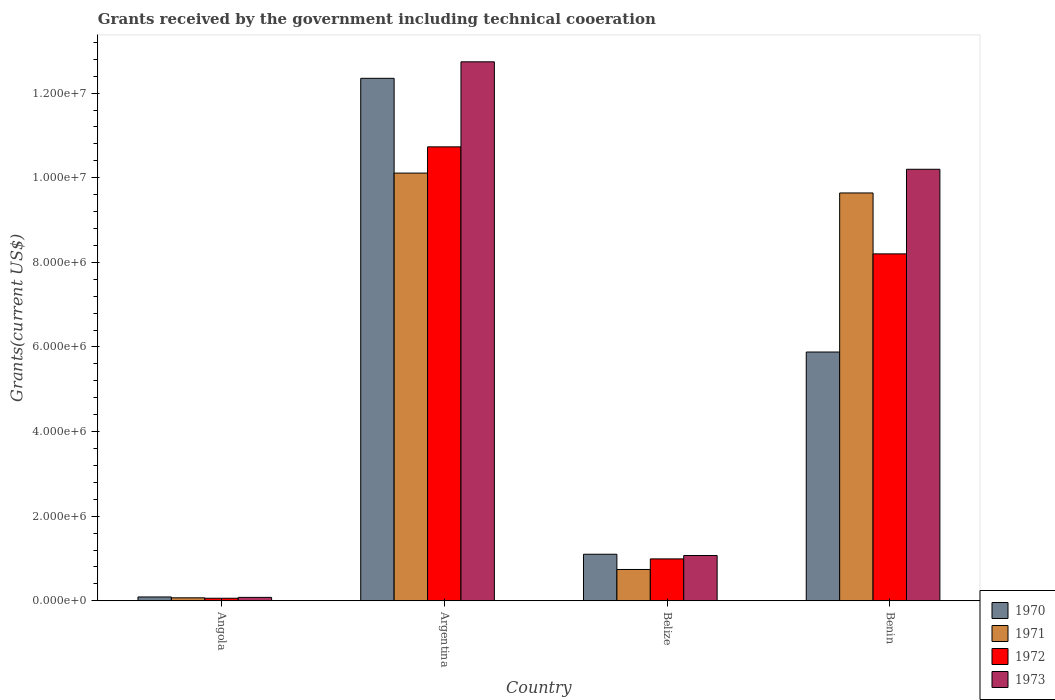How many different coloured bars are there?
Provide a succinct answer. 4. How many groups of bars are there?
Ensure brevity in your answer.  4. Are the number of bars per tick equal to the number of legend labels?
Give a very brief answer. Yes. Are the number of bars on each tick of the X-axis equal?
Provide a succinct answer. Yes. How many bars are there on the 3rd tick from the left?
Provide a succinct answer. 4. How many bars are there on the 4th tick from the right?
Your response must be concise. 4. What is the label of the 4th group of bars from the left?
Your response must be concise. Benin. In how many cases, is the number of bars for a given country not equal to the number of legend labels?
Offer a terse response. 0. What is the total grants received by the government in 1970 in Belize?
Your answer should be very brief. 1.10e+06. Across all countries, what is the maximum total grants received by the government in 1970?
Offer a very short reply. 1.24e+07. In which country was the total grants received by the government in 1970 minimum?
Provide a succinct answer. Angola. What is the total total grants received by the government in 1970 in the graph?
Give a very brief answer. 1.94e+07. What is the difference between the total grants received by the government in 1970 in Angola and that in Belize?
Your response must be concise. -1.01e+06. What is the difference between the total grants received by the government in 1973 in Benin and the total grants received by the government in 1970 in Belize?
Make the answer very short. 9.10e+06. What is the average total grants received by the government in 1971 per country?
Keep it short and to the point. 5.14e+06. What is the difference between the total grants received by the government of/in 1970 and total grants received by the government of/in 1973 in Benin?
Provide a short and direct response. -4.32e+06. What is the ratio of the total grants received by the government in 1970 in Angola to that in Belize?
Provide a succinct answer. 0.08. Is the total grants received by the government in 1973 in Angola less than that in Argentina?
Your answer should be very brief. Yes. What is the difference between the highest and the lowest total grants received by the government in 1971?
Your answer should be compact. 1.00e+07. In how many countries, is the total grants received by the government in 1973 greater than the average total grants received by the government in 1973 taken over all countries?
Provide a succinct answer. 2. What does the 1st bar from the right in Belize represents?
Give a very brief answer. 1973. Is it the case that in every country, the sum of the total grants received by the government in 1970 and total grants received by the government in 1972 is greater than the total grants received by the government in 1971?
Offer a very short reply. Yes. How many bars are there?
Keep it short and to the point. 16. Does the graph contain any zero values?
Your answer should be compact. No. Does the graph contain grids?
Your response must be concise. No. Where does the legend appear in the graph?
Provide a succinct answer. Bottom right. How many legend labels are there?
Offer a terse response. 4. What is the title of the graph?
Offer a terse response. Grants received by the government including technical cooeration. What is the label or title of the Y-axis?
Your answer should be compact. Grants(current US$). What is the Grants(current US$) of 1973 in Angola?
Provide a short and direct response. 8.00e+04. What is the Grants(current US$) of 1970 in Argentina?
Keep it short and to the point. 1.24e+07. What is the Grants(current US$) of 1971 in Argentina?
Offer a terse response. 1.01e+07. What is the Grants(current US$) in 1972 in Argentina?
Your answer should be very brief. 1.07e+07. What is the Grants(current US$) in 1973 in Argentina?
Provide a short and direct response. 1.27e+07. What is the Grants(current US$) in 1970 in Belize?
Give a very brief answer. 1.10e+06. What is the Grants(current US$) in 1971 in Belize?
Give a very brief answer. 7.40e+05. What is the Grants(current US$) of 1972 in Belize?
Provide a succinct answer. 9.90e+05. What is the Grants(current US$) of 1973 in Belize?
Ensure brevity in your answer.  1.07e+06. What is the Grants(current US$) in 1970 in Benin?
Your response must be concise. 5.88e+06. What is the Grants(current US$) in 1971 in Benin?
Your answer should be compact. 9.64e+06. What is the Grants(current US$) in 1972 in Benin?
Your response must be concise. 8.20e+06. What is the Grants(current US$) of 1973 in Benin?
Make the answer very short. 1.02e+07. Across all countries, what is the maximum Grants(current US$) of 1970?
Your answer should be very brief. 1.24e+07. Across all countries, what is the maximum Grants(current US$) in 1971?
Give a very brief answer. 1.01e+07. Across all countries, what is the maximum Grants(current US$) of 1972?
Your answer should be compact. 1.07e+07. Across all countries, what is the maximum Grants(current US$) in 1973?
Offer a very short reply. 1.27e+07. What is the total Grants(current US$) of 1970 in the graph?
Provide a succinct answer. 1.94e+07. What is the total Grants(current US$) in 1971 in the graph?
Offer a terse response. 2.06e+07. What is the total Grants(current US$) of 1972 in the graph?
Provide a succinct answer. 2.00e+07. What is the total Grants(current US$) in 1973 in the graph?
Your answer should be very brief. 2.41e+07. What is the difference between the Grants(current US$) in 1970 in Angola and that in Argentina?
Give a very brief answer. -1.23e+07. What is the difference between the Grants(current US$) of 1971 in Angola and that in Argentina?
Offer a very short reply. -1.00e+07. What is the difference between the Grants(current US$) in 1972 in Angola and that in Argentina?
Your response must be concise. -1.07e+07. What is the difference between the Grants(current US$) in 1973 in Angola and that in Argentina?
Give a very brief answer. -1.27e+07. What is the difference between the Grants(current US$) of 1970 in Angola and that in Belize?
Make the answer very short. -1.01e+06. What is the difference between the Grants(current US$) in 1971 in Angola and that in Belize?
Your response must be concise. -6.70e+05. What is the difference between the Grants(current US$) of 1972 in Angola and that in Belize?
Give a very brief answer. -9.30e+05. What is the difference between the Grants(current US$) of 1973 in Angola and that in Belize?
Your response must be concise. -9.90e+05. What is the difference between the Grants(current US$) in 1970 in Angola and that in Benin?
Ensure brevity in your answer.  -5.79e+06. What is the difference between the Grants(current US$) of 1971 in Angola and that in Benin?
Ensure brevity in your answer.  -9.57e+06. What is the difference between the Grants(current US$) in 1972 in Angola and that in Benin?
Provide a succinct answer. -8.14e+06. What is the difference between the Grants(current US$) in 1973 in Angola and that in Benin?
Ensure brevity in your answer.  -1.01e+07. What is the difference between the Grants(current US$) in 1970 in Argentina and that in Belize?
Keep it short and to the point. 1.12e+07. What is the difference between the Grants(current US$) in 1971 in Argentina and that in Belize?
Provide a succinct answer. 9.37e+06. What is the difference between the Grants(current US$) of 1972 in Argentina and that in Belize?
Provide a short and direct response. 9.74e+06. What is the difference between the Grants(current US$) of 1973 in Argentina and that in Belize?
Provide a succinct answer. 1.17e+07. What is the difference between the Grants(current US$) in 1970 in Argentina and that in Benin?
Give a very brief answer. 6.47e+06. What is the difference between the Grants(current US$) in 1971 in Argentina and that in Benin?
Give a very brief answer. 4.70e+05. What is the difference between the Grants(current US$) of 1972 in Argentina and that in Benin?
Your answer should be very brief. 2.53e+06. What is the difference between the Grants(current US$) in 1973 in Argentina and that in Benin?
Keep it short and to the point. 2.54e+06. What is the difference between the Grants(current US$) of 1970 in Belize and that in Benin?
Ensure brevity in your answer.  -4.78e+06. What is the difference between the Grants(current US$) of 1971 in Belize and that in Benin?
Offer a terse response. -8.90e+06. What is the difference between the Grants(current US$) in 1972 in Belize and that in Benin?
Your answer should be compact. -7.21e+06. What is the difference between the Grants(current US$) in 1973 in Belize and that in Benin?
Offer a terse response. -9.13e+06. What is the difference between the Grants(current US$) of 1970 in Angola and the Grants(current US$) of 1971 in Argentina?
Your response must be concise. -1.00e+07. What is the difference between the Grants(current US$) in 1970 in Angola and the Grants(current US$) in 1972 in Argentina?
Offer a terse response. -1.06e+07. What is the difference between the Grants(current US$) of 1970 in Angola and the Grants(current US$) of 1973 in Argentina?
Provide a short and direct response. -1.26e+07. What is the difference between the Grants(current US$) of 1971 in Angola and the Grants(current US$) of 1972 in Argentina?
Give a very brief answer. -1.07e+07. What is the difference between the Grants(current US$) of 1971 in Angola and the Grants(current US$) of 1973 in Argentina?
Give a very brief answer. -1.27e+07. What is the difference between the Grants(current US$) of 1972 in Angola and the Grants(current US$) of 1973 in Argentina?
Provide a succinct answer. -1.27e+07. What is the difference between the Grants(current US$) in 1970 in Angola and the Grants(current US$) in 1971 in Belize?
Make the answer very short. -6.50e+05. What is the difference between the Grants(current US$) of 1970 in Angola and the Grants(current US$) of 1972 in Belize?
Keep it short and to the point. -9.00e+05. What is the difference between the Grants(current US$) of 1970 in Angola and the Grants(current US$) of 1973 in Belize?
Provide a short and direct response. -9.80e+05. What is the difference between the Grants(current US$) of 1971 in Angola and the Grants(current US$) of 1972 in Belize?
Give a very brief answer. -9.20e+05. What is the difference between the Grants(current US$) of 1972 in Angola and the Grants(current US$) of 1973 in Belize?
Your answer should be very brief. -1.01e+06. What is the difference between the Grants(current US$) in 1970 in Angola and the Grants(current US$) in 1971 in Benin?
Offer a very short reply. -9.55e+06. What is the difference between the Grants(current US$) in 1970 in Angola and the Grants(current US$) in 1972 in Benin?
Provide a short and direct response. -8.11e+06. What is the difference between the Grants(current US$) in 1970 in Angola and the Grants(current US$) in 1973 in Benin?
Offer a very short reply. -1.01e+07. What is the difference between the Grants(current US$) of 1971 in Angola and the Grants(current US$) of 1972 in Benin?
Give a very brief answer. -8.13e+06. What is the difference between the Grants(current US$) in 1971 in Angola and the Grants(current US$) in 1973 in Benin?
Ensure brevity in your answer.  -1.01e+07. What is the difference between the Grants(current US$) of 1972 in Angola and the Grants(current US$) of 1973 in Benin?
Your answer should be very brief. -1.01e+07. What is the difference between the Grants(current US$) in 1970 in Argentina and the Grants(current US$) in 1971 in Belize?
Keep it short and to the point. 1.16e+07. What is the difference between the Grants(current US$) of 1970 in Argentina and the Grants(current US$) of 1972 in Belize?
Offer a terse response. 1.14e+07. What is the difference between the Grants(current US$) of 1970 in Argentina and the Grants(current US$) of 1973 in Belize?
Provide a short and direct response. 1.13e+07. What is the difference between the Grants(current US$) in 1971 in Argentina and the Grants(current US$) in 1972 in Belize?
Keep it short and to the point. 9.12e+06. What is the difference between the Grants(current US$) in 1971 in Argentina and the Grants(current US$) in 1973 in Belize?
Your answer should be compact. 9.04e+06. What is the difference between the Grants(current US$) of 1972 in Argentina and the Grants(current US$) of 1973 in Belize?
Your answer should be very brief. 9.66e+06. What is the difference between the Grants(current US$) of 1970 in Argentina and the Grants(current US$) of 1971 in Benin?
Provide a succinct answer. 2.71e+06. What is the difference between the Grants(current US$) in 1970 in Argentina and the Grants(current US$) in 1972 in Benin?
Make the answer very short. 4.15e+06. What is the difference between the Grants(current US$) in 1970 in Argentina and the Grants(current US$) in 1973 in Benin?
Your answer should be very brief. 2.15e+06. What is the difference between the Grants(current US$) of 1971 in Argentina and the Grants(current US$) of 1972 in Benin?
Offer a very short reply. 1.91e+06. What is the difference between the Grants(current US$) in 1972 in Argentina and the Grants(current US$) in 1973 in Benin?
Offer a terse response. 5.30e+05. What is the difference between the Grants(current US$) of 1970 in Belize and the Grants(current US$) of 1971 in Benin?
Provide a succinct answer. -8.54e+06. What is the difference between the Grants(current US$) of 1970 in Belize and the Grants(current US$) of 1972 in Benin?
Provide a short and direct response. -7.10e+06. What is the difference between the Grants(current US$) in 1970 in Belize and the Grants(current US$) in 1973 in Benin?
Make the answer very short. -9.10e+06. What is the difference between the Grants(current US$) of 1971 in Belize and the Grants(current US$) of 1972 in Benin?
Make the answer very short. -7.46e+06. What is the difference between the Grants(current US$) of 1971 in Belize and the Grants(current US$) of 1973 in Benin?
Your response must be concise. -9.46e+06. What is the difference between the Grants(current US$) in 1972 in Belize and the Grants(current US$) in 1973 in Benin?
Keep it short and to the point. -9.21e+06. What is the average Grants(current US$) of 1970 per country?
Provide a succinct answer. 4.86e+06. What is the average Grants(current US$) in 1971 per country?
Keep it short and to the point. 5.14e+06. What is the average Grants(current US$) of 1972 per country?
Provide a short and direct response. 5.00e+06. What is the average Grants(current US$) of 1973 per country?
Your response must be concise. 6.02e+06. What is the difference between the Grants(current US$) in 1971 and Grants(current US$) in 1972 in Angola?
Make the answer very short. 10000. What is the difference between the Grants(current US$) in 1971 and Grants(current US$) in 1973 in Angola?
Provide a short and direct response. -10000. What is the difference between the Grants(current US$) in 1970 and Grants(current US$) in 1971 in Argentina?
Your answer should be very brief. 2.24e+06. What is the difference between the Grants(current US$) in 1970 and Grants(current US$) in 1972 in Argentina?
Provide a succinct answer. 1.62e+06. What is the difference between the Grants(current US$) of 1970 and Grants(current US$) of 1973 in Argentina?
Offer a terse response. -3.90e+05. What is the difference between the Grants(current US$) in 1971 and Grants(current US$) in 1972 in Argentina?
Keep it short and to the point. -6.20e+05. What is the difference between the Grants(current US$) in 1971 and Grants(current US$) in 1973 in Argentina?
Your answer should be compact. -2.63e+06. What is the difference between the Grants(current US$) in 1972 and Grants(current US$) in 1973 in Argentina?
Your answer should be compact. -2.01e+06. What is the difference between the Grants(current US$) in 1970 and Grants(current US$) in 1971 in Belize?
Keep it short and to the point. 3.60e+05. What is the difference between the Grants(current US$) in 1971 and Grants(current US$) in 1973 in Belize?
Ensure brevity in your answer.  -3.30e+05. What is the difference between the Grants(current US$) in 1972 and Grants(current US$) in 1973 in Belize?
Offer a terse response. -8.00e+04. What is the difference between the Grants(current US$) of 1970 and Grants(current US$) of 1971 in Benin?
Provide a short and direct response. -3.76e+06. What is the difference between the Grants(current US$) of 1970 and Grants(current US$) of 1972 in Benin?
Make the answer very short. -2.32e+06. What is the difference between the Grants(current US$) in 1970 and Grants(current US$) in 1973 in Benin?
Give a very brief answer. -4.32e+06. What is the difference between the Grants(current US$) of 1971 and Grants(current US$) of 1972 in Benin?
Provide a short and direct response. 1.44e+06. What is the difference between the Grants(current US$) of 1971 and Grants(current US$) of 1973 in Benin?
Give a very brief answer. -5.60e+05. What is the difference between the Grants(current US$) of 1972 and Grants(current US$) of 1973 in Benin?
Keep it short and to the point. -2.00e+06. What is the ratio of the Grants(current US$) in 1970 in Angola to that in Argentina?
Provide a succinct answer. 0.01. What is the ratio of the Grants(current US$) of 1971 in Angola to that in Argentina?
Ensure brevity in your answer.  0.01. What is the ratio of the Grants(current US$) of 1972 in Angola to that in Argentina?
Your answer should be very brief. 0.01. What is the ratio of the Grants(current US$) of 1973 in Angola to that in Argentina?
Offer a very short reply. 0.01. What is the ratio of the Grants(current US$) of 1970 in Angola to that in Belize?
Make the answer very short. 0.08. What is the ratio of the Grants(current US$) in 1971 in Angola to that in Belize?
Offer a terse response. 0.09. What is the ratio of the Grants(current US$) in 1972 in Angola to that in Belize?
Make the answer very short. 0.06. What is the ratio of the Grants(current US$) of 1973 in Angola to that in Belize?
Your response must be concise. 0.07. What is the ratio of the Grants(current US$) of 1970 in Angola to that in Benin?
Keep it short and to the point. 0.02. What is the ratio of the Grants(current US$) of 1971 in Angola to that in Benin?
Provide a short and direct response. 0.01. What is the ratio of the Grants(current US$) in 1972 in Angola to that in Benin?
Keep it short and to the point. 0.01. What is the ratio of the Grants(current US$) of 1973 in Angola to that in Benin?
Offer a very short reply. 0.01. What is the ratio of the Grants(current US$) of 1970 in Argentina to that in Belize?
Provide a short and direct response. 11.23. What is the ratio of the Grants(current US$) of 1971 in Argentina to that in Belize?
Your answer should be very brief. 13.66. What is the ratio of the Grants(current US$) of 1972 in Argentina to that in Belize?
Keep it short and to the point. 10.84. What is the ratio of the Grants(current US$) of 1973 in Argentina to that in Belize?
Give a very brief answer. 11.91. What is the ratio of the Grants(current US$) in 1970 in Argentina to that in Benin?
Keep it short and to the point. 2.1. What is the ratio of the Grants(current US$) of 1971 in Argentina to that in Benin?
Your response must be concise. 1.05. What is the ratio of the Grants(current US$) in 1972 in Argentina to that in Benin?
Keep it short and to the point. 1.31. What is the ratio of the Grants(current US$) of 1973 in Argentina to that in Benin?
Your answer should be compact. 1.25. What is the ratio of the Grants(current US$) of 1970 in Belize to that in Benin?
Ensure brevity in your answer.  0.19. What is the ratio of the Grants(current US$) in 1971 in Belize to that in Benin?
Your answer should be compact. 0.08. What is the ratio of the Grants(current US$) in 1972 in Belize to that in Benin?
Your answer should be compact. 0.12. What is the ratio of the Grants(current US$) in 1973 in Belize to that in Benin?
Offer a terse response. 0.1. What is the difference between the highest and the second highest Grants(current US$) of 1970?
Keep it short and to the point. 6.47e+06. What is the difference between the highest and the second highest Grants(current US$) of 1972?
Your answer should be compact. 2.53e+06. What is the difference between the highest and the second highest Grants(current US$) of 1973?
Offer a very short reply. 2.54e+06. What is the difference between the highest and the lowest Grants(current US$) in 1970?
Offer a terse response. 1.23e+07. What is the difference between the highest and the lowest Grants(current US$) of 1971?
Your answer should be very brief. 1.00e+07. What is the difference between the highest and the lowest Grants(current US$) in 1972?
Keep it short and to the point. 1.07e+07. What is the difference between the highest and the lowest Grants(current US$) in 1973?
Your response must be concise. 1.27e+07. 